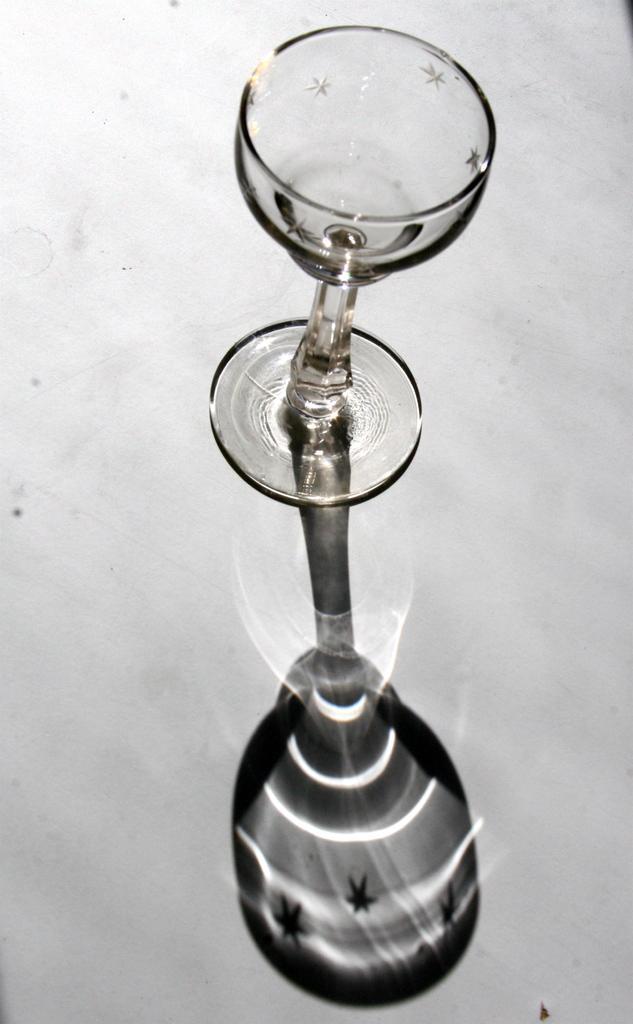Describe this image in one or two sentences. In the center of the image a glass is there. 